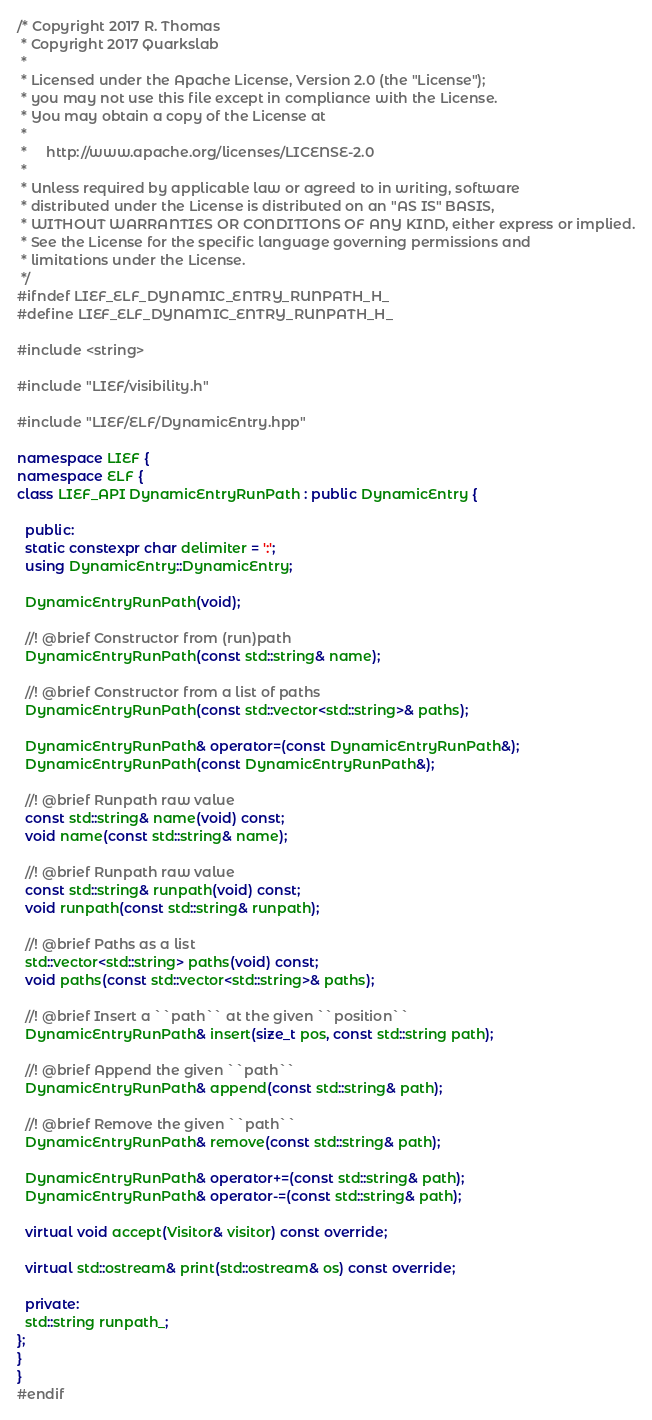Convert code to text. <code><loc_0><loc_0><loc_500><loc_500><_C++_>/* Copyright 2017 R. Thomas
 * Copyright 2017 Quarkslab
 *
 * Licensed under the Apache License, Version 2.0 (the "License");
 * you may not use this file except in compliance with the License.
 * You may obtain a copy of the License at
 *
 *     http://www.apache.org/licenses/LICENSE-2.0
 *
 * Unless required by applicable law or agreed to in writing, software
 * distributed under the License is distributed on an "AS IS" BASIS,
 * WITHOUT WARRANTIES OR CONDITIONS OF ANY KIND, either express or implied.
 * See the License for the specific language governing permissions and
 * limitations under the License.
 */
#ifndef LIEF_ELF_DYNAMIC_ENTRY_RUNPATH_H_
#define LIEF_ELF_DYNAMIC_ENTRY_RUNPATH_H_

#include <string>

#include "LIEF/visibility.h"

#include "LIEF/ELF/DynamicEntry.hpp"

namespace LIEF {
namespace ELF {
class LIEF_API DynamicEntryRunPath : public DynamicEntry {

  public:
  static constexpr char delimiter = ':';
  using DynamicEntry::DynamicEntry;

  DynamicEntryRunPath(void);

  //! @brief Constructor from (run)path
  DynamicEntryRunPath(const std::string& name);

  //! @brief Constructor from a list of paths
  DynamicEntryRunPath(const std::vector<std::string>& paths);

  DynamicEntryRunPath& operator=(const DynamicEntryRunPath&);
  DynamicEntryRunPath(const DynamicEntryRunPath&);

  //! @brief Runpath raw value
  const std::string& name(void) const;
  void name(const std::string& name);

  //! @brief Runpath raw value
  const std::string& runpath(void) const;
  void runpath(const std::string& runpath);

  //! @brief Paths as a list
  std::vector<std::string> paths(void) const;
  void paths(const std::vector<std::string>& paths);

  //! @brief Insert a ``path`` at the given ``position``
  DynamicEntryRunPath& insert(size_t pos, const std::string path);

  //! @brief Append the given ``path``
  DynamicEntryRunPath& append(const std::string& path);

  //! @brief Remove the given ``path``
  DynamicEntryRunPath& remove(const std::string& path);

  DynamicEntryRunPath& operator+=(const std::string& path);
  DynamicEntryRunPath& operator-=(const std::string& path);

  virtual void accept(Visitor& visitor) const override;

  virtual std::ostream& print(std::ostream& os) const override;

  private:
  std::string runpath_;
};
}
}
#endif
</code> 